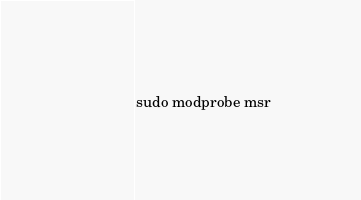<code> <loc_0><loc_0><loc_500><loc_500><_Bash_>sudo modprobe msr
</code> 